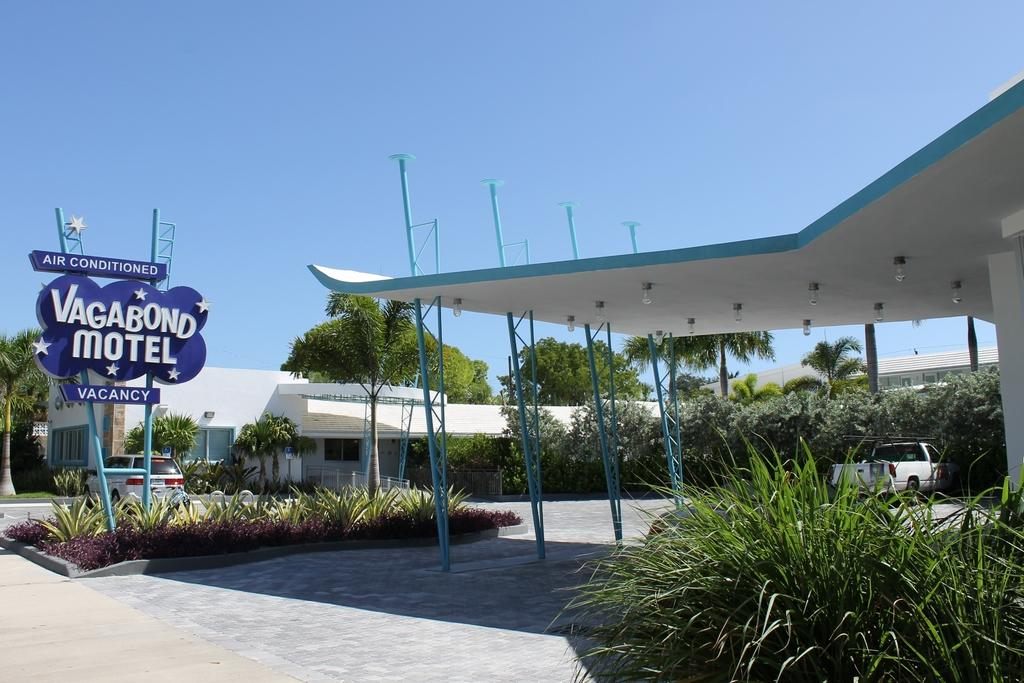<image>
Offer a succinct explanation of the picture presented. a sign reading Vagabond motel says that there are vacancies 